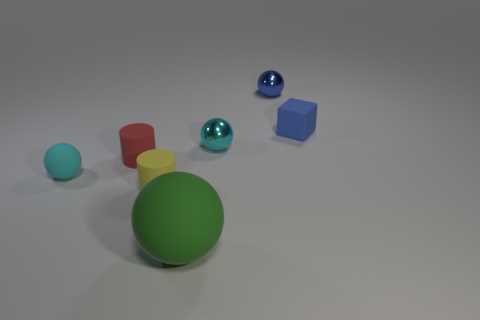Subtract all tiny blue spheres. How many spheres are left? 3 Subtract all tiny green metallic spheres. Subtract all small spheres. How many objects are left? 4 Add 1 small yellow matte cylinders. How many small yellow matte cylinders are left? 2 Add 1 tiny yellow cylinders. How many tiny yellow cylinders exist? 2 Add 3 tiny rubber cylinders. How many objects exist? 10 Subtract all red cylinders. How many cylinders are left? 1 Subtract 1 yellow cylinders. How many objects are left? 6 Subtract all blocks. How many objects are left? 6 Subtract 1 cubes. How many cubes are left? 0 Subtract all blue cylinders. Subtract all brown balls. How many cylinders are left? 2 